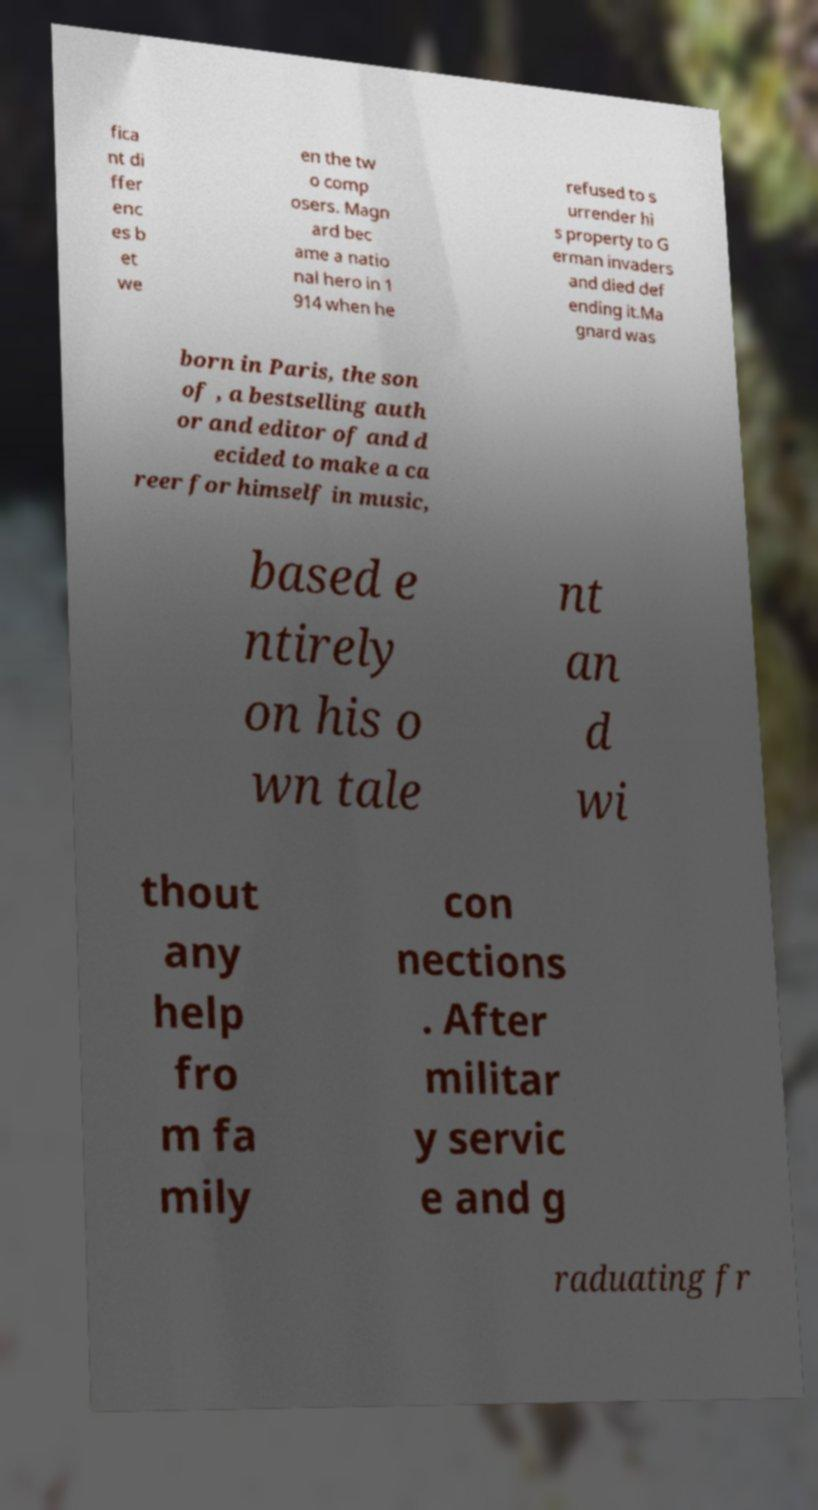Can you accurately transcribe the text from the provided image for me? fica nt di ffer enc es b et we en the tw o comp osers. Magn ard bec ame a natio nal hero in 1 914 when he refused to s urrender hi s property to G erman invaders and died def ending it.Ma gnard was born in Paris, the son of , a bestselling auth or and editor of and d ecided to make a ca reer for himself in music, based e ntirely on his o wn tale nt an d wi thout any help fro m fa mily con nections . After militar y servic e and g raduating fr 